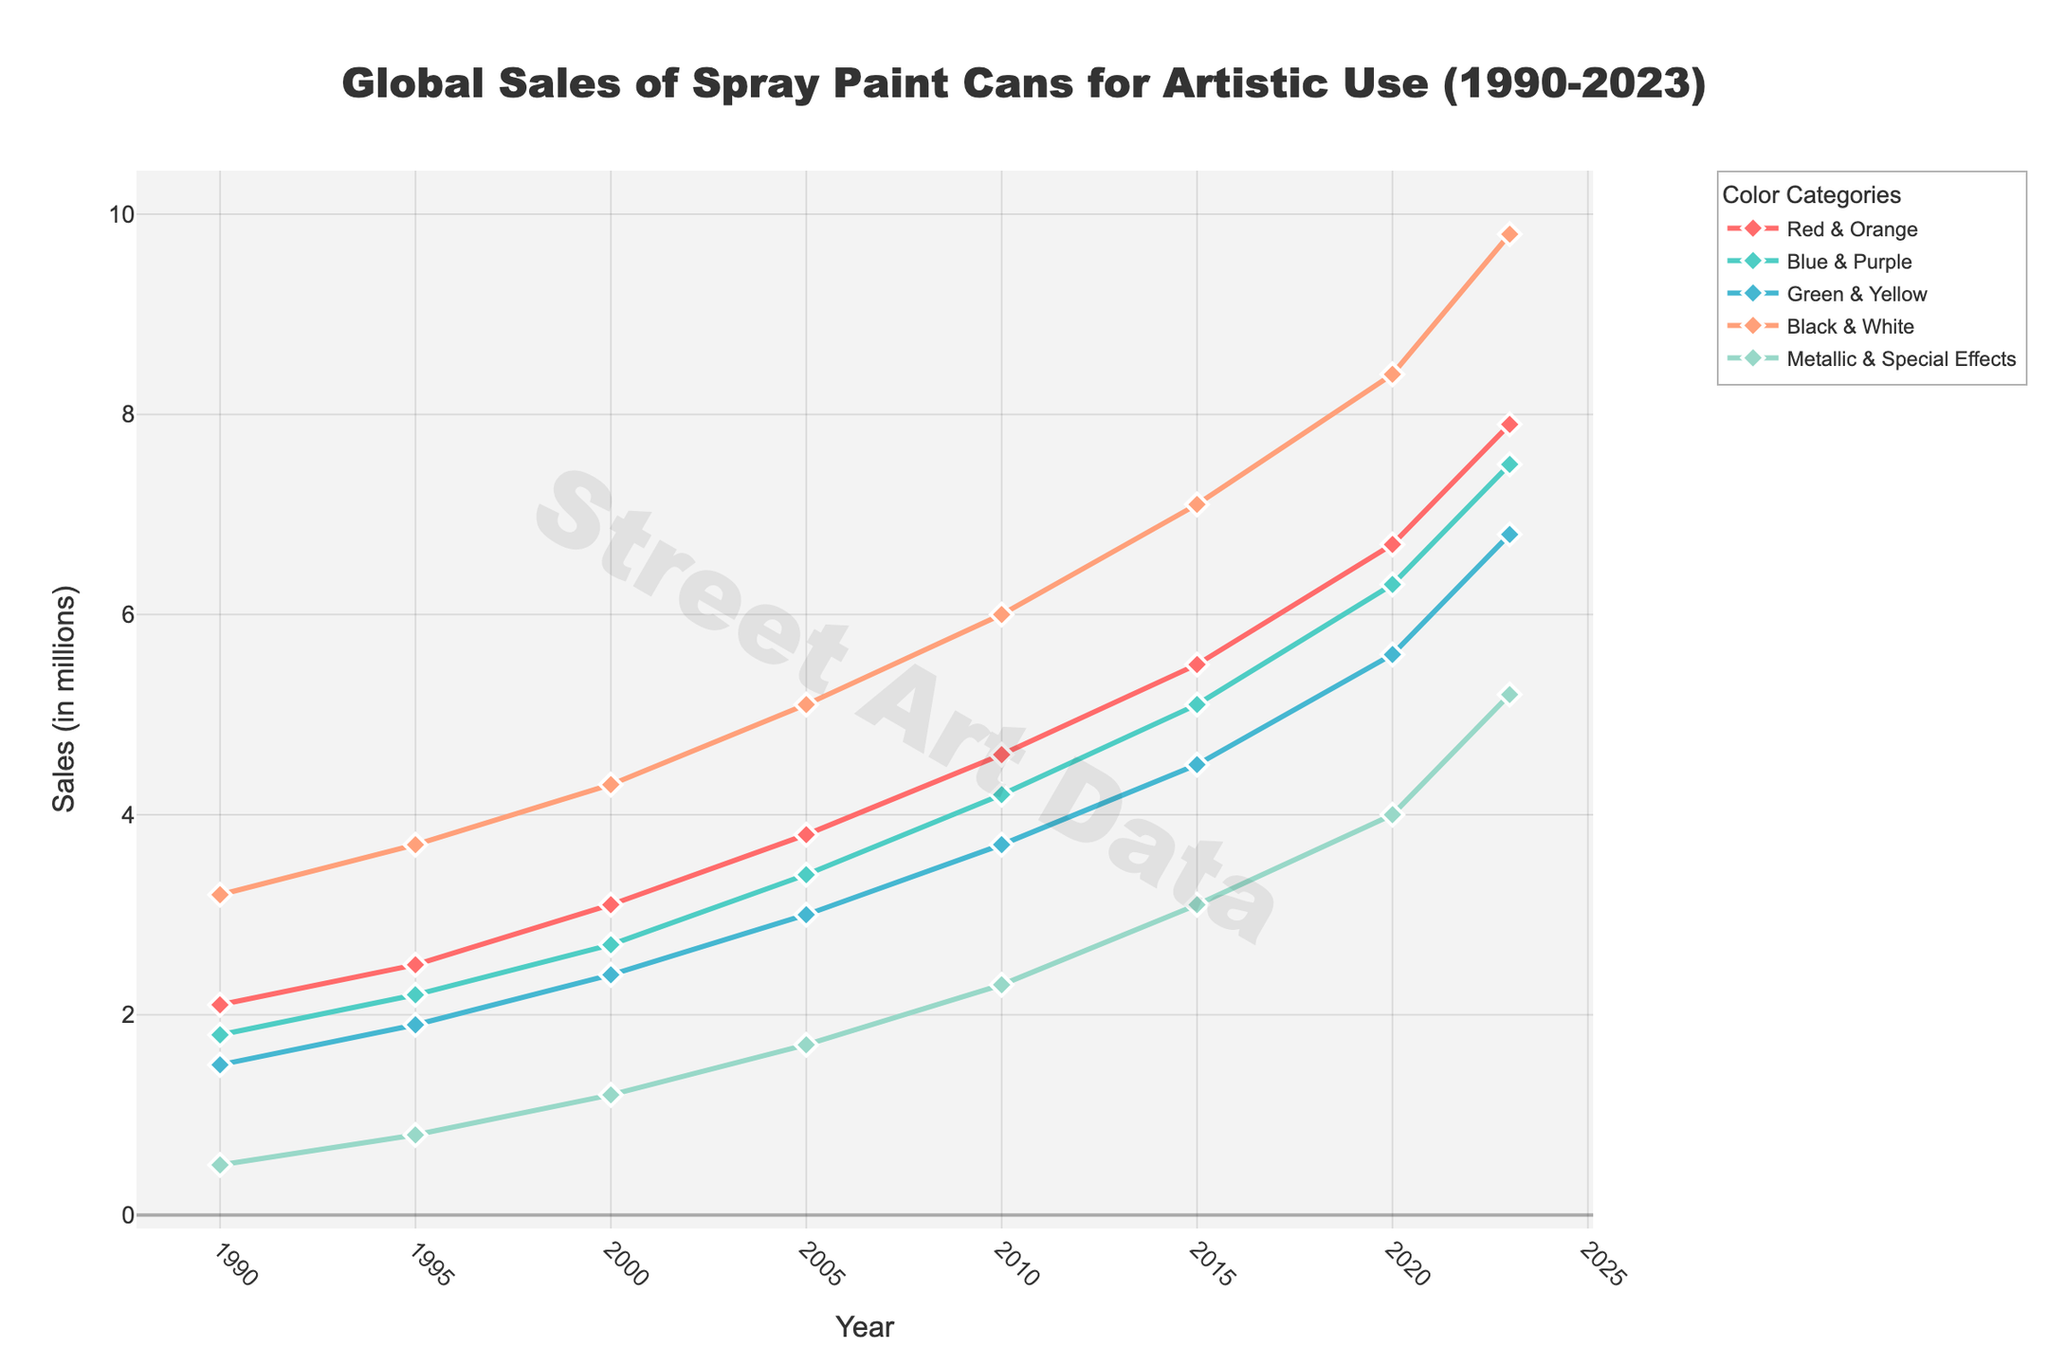what is the overall trend for "Red & Orange" sales from 1990 to 2023? To determine the trend, look at the changes in sales from year to year. "Red & Orange" sales consistently increased from 2.1 million in 1990 to 7.9 million in 2023. This indicates a consistent upward trend over the period.
Answer: Consistent upward trend Which color category had the highest sales in 2023? To find the category with the highest sales, compare the values for each color category in 2023. "Black & White" had the highest sales with 9.8 million units.
Answer: Black & White How did the sales of "Metallic & Special Effects" change from 1995 to 2020? To determine the change, compare the sales in 1995 with those in 2020. In 1995, sales were 0.8 million, and in 2020, they were 4.0 million. The change is 4.0 - 0.8 = 3.2 million.
Answer: Increased by 3.2 million By how much did the sales of "Blue & Purple" grow from 2000 to 2010? Find the sales for "Blue & Purple" in 2000 and 2010, then calculate the difference. In 2000, sales were 2.7 million, and in 2010, they were 4.2 million. The growth is 4.2 - 2.7 = 1.5 million.
Answer: 1.5 million Which color categories have seen their sales more than double between 1990 and 2023? First, check the sales for each category in 1990 and 2023. Then, see if the 2023 sales are more than twice the 1990 sales. The categories "Red & Orange", "Blue & Purple", "Green & Yellow", "Black & White", and "Metallic & Special Effects" have all seen their sales more than double over this period.
Answer: All categories In which year did "Green & Yellow" sales surpass the 3 million mark? Check the sales figures for "Green & Yellow" over the years. In 2005, sales reached 3.0 million, and in 2010, they surpassed it with 3.7 million. So, it was in 2010.
Answer: 2010 What is the total combined sales for "Red & Orange" and "Black & White" in 2015? Add the sales for both categories in 2015. "Red & Orange" had 5.5 million and "Black & White" had 7.1 million. Total is 5.5 + 7.1 = 12.6 million.
Answer: 12.6 million Between which consecutive years did "Metallic & Special Effects" see the largest increase in sales? Compare the year-over-year sales increments for "Metallic & Special Effects". The largest increase was between 2015 (3.1 million) and 2020 (4.0 million), an increase of 4.0 - 3.1 = 0.9 million.
Answer: 2015 and 2020 